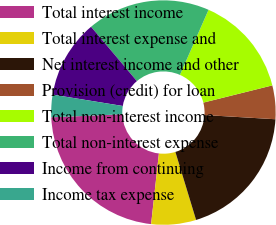Convert chart to OTSL. <chart><loc_0><loc_0><loc_500><loc_500><pie_chart><fcel>Total interest income<fcel>Total interest expense and<fcel>Net interest income and other<fcel>Provision (credit) for loan<fcel>Total non-interest income<fcel>Total non-interest expense<fcel>Income from continuing<fcel>Income tax expense<nl><fcel>22.58%<fcel>6.45%<fcel>19.35%<fcel>4.84%<fcel>14.52%<fcel>17.74%<fcel>11.29%<fcel>3.23%<nl></chart> 